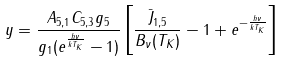<formula> <loc_0><loc_0><loc_500><loc_500>y = \frac { A _ { 5 , 1 } C _ { 5 , 3 } g _ { 5 } } { g _ { 1 } ( e ^ { \frac { h \nu } { k T _ { K } } } - 1 ) } \left [ \frac { \bar { J } _ { 1 , 5 } } { B _ { \nu } ( T _ { K } ) } - 1 + e ^ { - \frac { h \nu } { k T _ { K } } } \right ]</formula> 